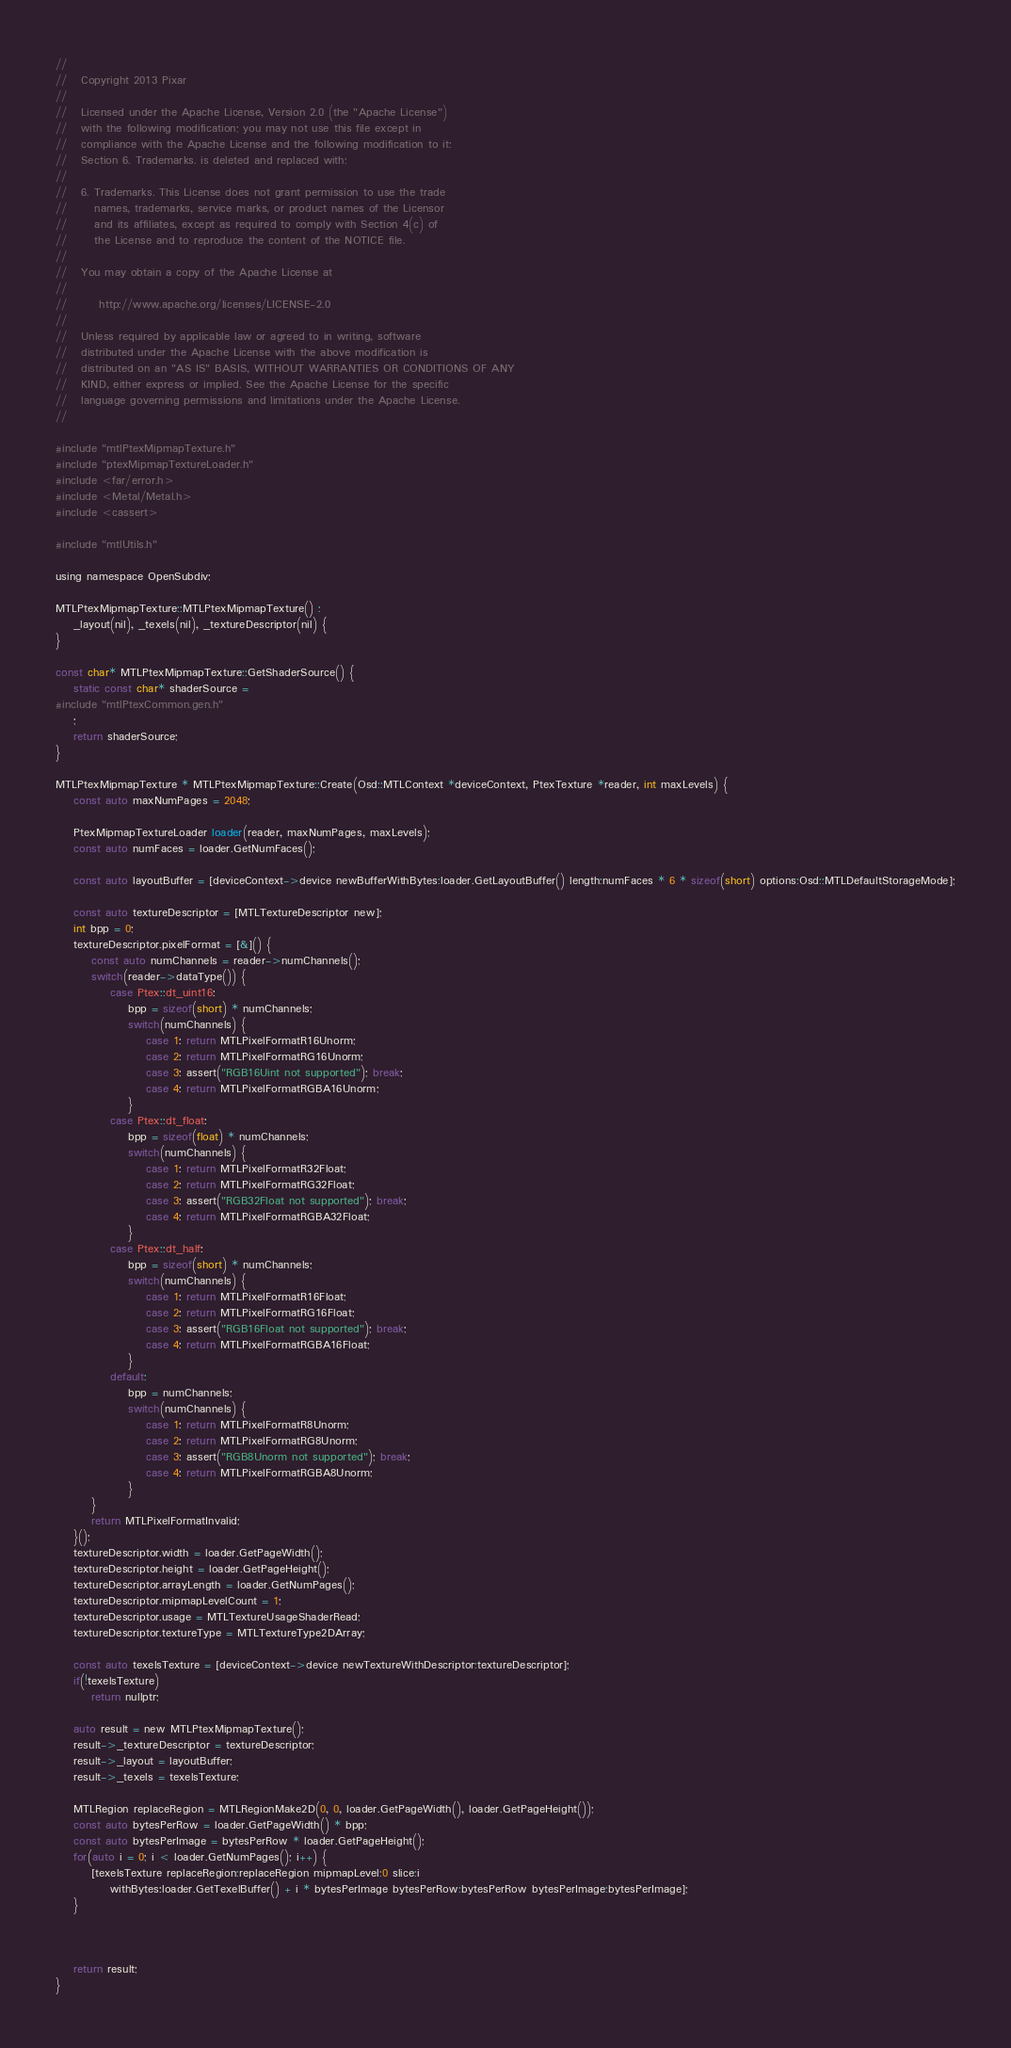Convert code to text. <code><loc_0><loc_0><loc_500><loc_500><_ObjectiveC_>//
//   Copyright 2013 Pixar
//
//   Licensed under the Apache License, Version 2.0 (the "Apache License")
//   with the following modification; you may not use this file except in
//   compliance with the Apache License and the following modification to it:
//   Section 6. Trademarks. is deleted and replaced with:
//
//   6. Trademarks. This License does not grant permission to use the trade
//      names, trademarks, service marks, or product names of the Licensor
//      and its affiliates, except as required to comply with Section 4(c) of
//      the License and to reproduce the content of the NOTICE file.
//
//   You may obtain a copy of the Apache License at
//
//       http://www.apache.org/licenses/LICENSE-2.0
//
//   Unless required by applicable law or agreed to in writing, software
//   distributed under the Apache License with the above modification is
//   distributed on an "AS IS" BASIS, WITHOUT WARRANTIES OR CONDITIONS OF ANY
//   KIND, either express or implied. See the Apache License for the specific
//   language governing permissions and limitations under the Apache License.
//

#include "mtlPtexMipmapTexture.h"
#include "ptexMipmapTextureLoader.h"
#include <far/error.h>
#include <Metal/Metal.h>
#include <cassert>

#include "mtlUtils.h"

using namespace OpenSubdiv;

MTLPtexMipmapTexture::MTLPtexMipmapTexture() :
    _layout(nil), _texels(nil), _textureDescriptor(nil) {
}

const char* MTLPtexMipmapTexture::GetShaderSource() {
    static const char* shaderSource =
#include "mtlPtexCommon.gen.h"
    ;
    return shaderSource;
}

MTLPtexMipmapTexture * MTLPtexMipmapTexture::Create(Osd::MTLContext *deviceContext, PtexTexture *reader, int maxLevels) {
    const auto maxNumPages = 2048;

    PtexMipmapTextureLoader loader(reader, maxNumPages, maxLevels);
    const auto numFaces = loader.GetNumFaces();
    
    const auto layoutBuffer = [deviceContext->device newBufferWithBytes:loader.GetLayoutBuffer() length:numFaces * 6 * sizeof(short) options:Osd::MTLDefaultStorageMode];
    
    const auto textureDescriptor = [MTLTextureDescriptor new];
    int bpp = 0;
    textureDescriptor.pixelFormat = [&]() {
        const auto numChannels = reader->numChannels();
        switch(reader->dataType()) {
            case Ptex::dt_uint16:
                bpp = sizeof(short) * numChannels;
                switch(numChannels) {
                    case 1: return MTLPixelFormatR16Unorm;
                    case 2: return MTLPixelFormatRG16Unorm;
                    case 3: assert("RGB16Uint not supported"); break;
                    case 4: return MTLPixelFormatRGBA16Unorm;
                }
            case Ptex::dt_float:
                bpp = sizeof(float) * numChannels;
                switch(numChannels) {
                    case 1: return MTLPixelFormatR32Float;
                    case 2: return MTLPixelFormatRG32Float;
                    case 3: assert("RGB32Float not supported"); break;
                    case 4: return MTLPixelFormatRGBA32Float;
                }
            case Ptex::dt_half:
                bpp = sizeof(short) * numChannels;
                switch(numChannels) {
                    case 1: return MTLPixelFormatR16Float;
                    case 2: return MTLPixelFormatRG16Float;
                    case 3: assert("RGB16Float not supported"); break;
                    case 4: return MTLPixelFormatRGBA16Float;
                }
            default:
                bpp = numChannels;
                switch(numChannels) {
                    case 1: return MTLPixelFormatR8Unorm;
                    case 2: return MTLPixelFormatRG8Unorm;
                    case 3: assert("RGB8Unorm not supported"); break;
                    case 4: return MTLPixelFormatRGBA8Unorm;
                }
        }
        return MTLPixelFormatInvalid;
    }();
    textureDescriptor.width = loader.GetPageWidth();
    textureDescriptor.height = loader.GetPageHeight();
    textureDescriptor.arrayLength = loader.GetNumPages();
    textureDescriptor.mipmapLevelCount = 1;
    textureDescriptor.usage = MTLTextureUsageShaderRead;
    textureDescriptor.textureType = MTLTextureType2DArray;
    
    const auto texelsTexture = [deviceContext->device newTextureWithDescriptor:textureDescriptor];
    if(!texelsTexture)
        return nullptr;
    
    auto result = new MTLPtexMipmapTexture();
    result->_textureDescriptor = textureDescriptor;
    result->_layout = layoutBuffer;
    result->_texels = texelsTexture;

    MTLRegion replaceRegion = MTLRegionMake2D(0, 0, loader.GetPageWidth(), loader.GetPageHeight());
    const auto bytesPerRow = loader.GetPageWidth() * bpp;
    const auto bytesPerImage = bytesPerRow * loader.GetPageHeight();
    for(auto i = 0; i < loader.GetNumPages(); i++) {
        [texelsTexture replaceRegion:replaceRegion mipmapLevel:0 slice:i
            withBytes:loader.GetTexelBuffer() + i * bytesPerImage bytesPerRow:bytesPerRow bytesPerImage:bytesPerImage];
    }



    return result;
}
</code> 